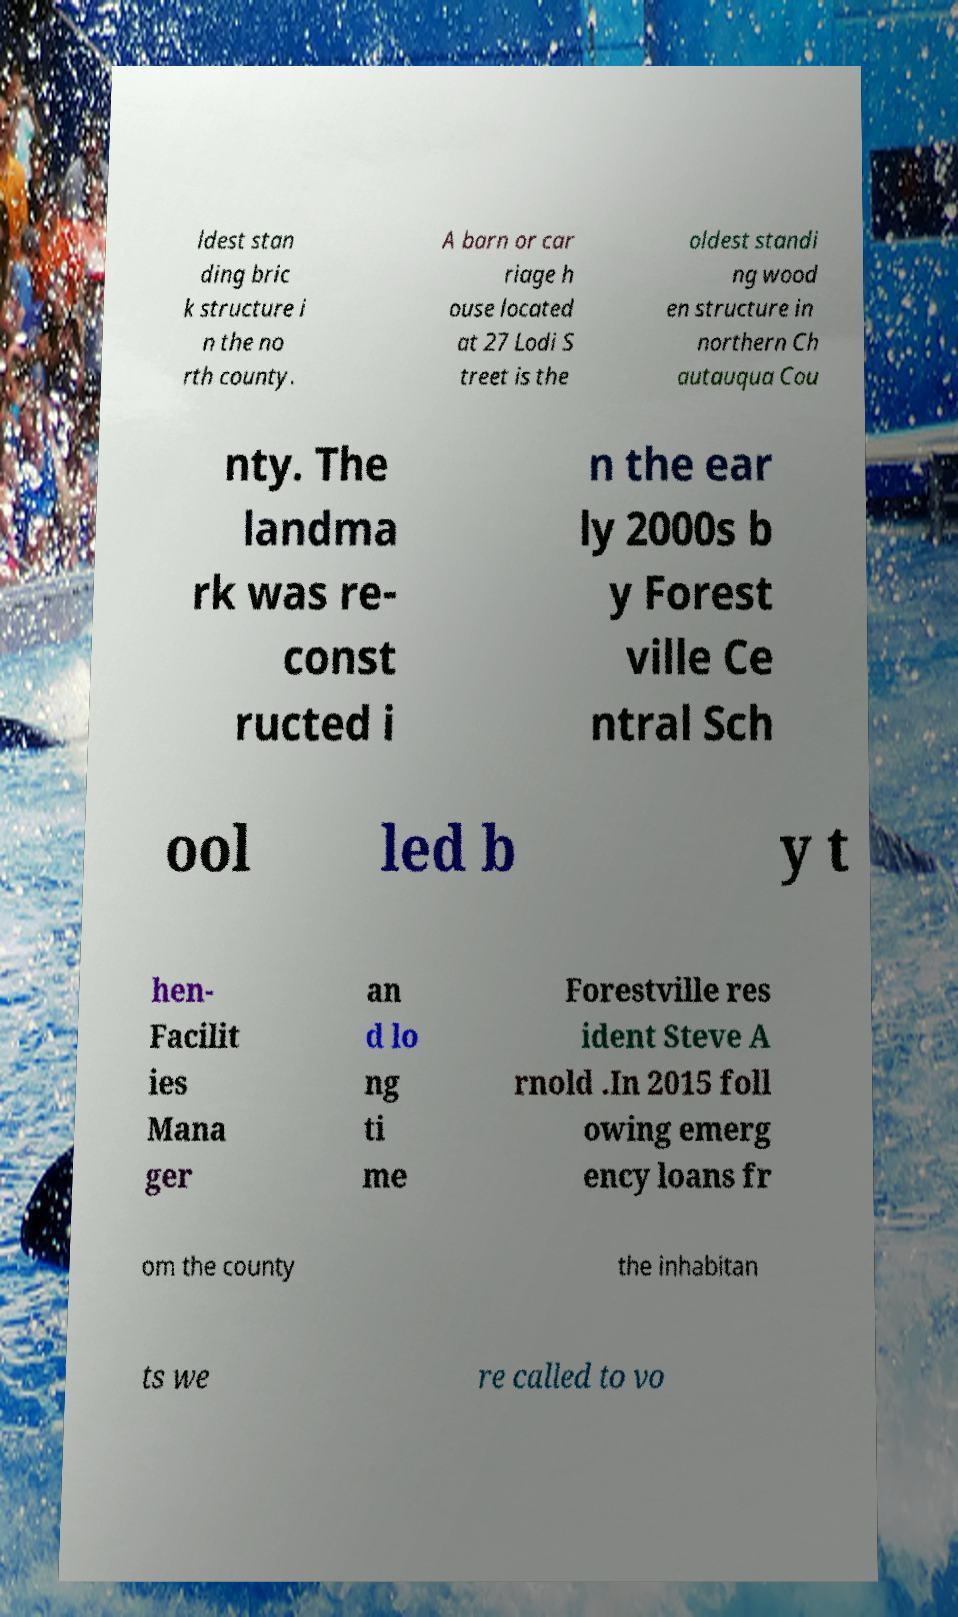For documentation purposes, I need the text within this image transcribed. Could you provide that? ldest stan ding bric k structure i n the no rth county. A barn or car riage h ouse located at 27 Lodi S treet is the oldest standi ng wood en structure in northern Ch autauqua Cou nty. The landma rk was re- const ructed i n the ear ly 2000s b y Forest ville Ce ntral Sch ool led b y t hen- Facilit ies Mana ger an d lo ng ti me Forestville res ident Steve A rnold .In 2015 foll owing emerg ency loans fr om the county the inhabitan ts we re called to vo 